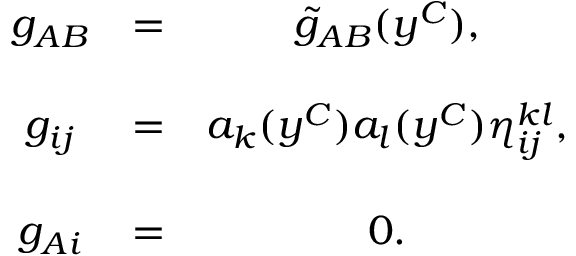<formula> <loc_0><loc_0><loc_500><loc_500>\begin{array} { c c c } { { g _ { A B } } } & { = } & { { \tilde { g } _ { A B } ( y ^ { C } ) , } } \\ { { g _ { i j } } } & { = } & { { a _ { k } ( y ^ { C } ) a _ { l } ( y ^ { C } ) \eta _ { i j } ^ { k l } , } } \\ { { g _ { A i } } } & { = } & { 0 . } \end{array}</formula> 